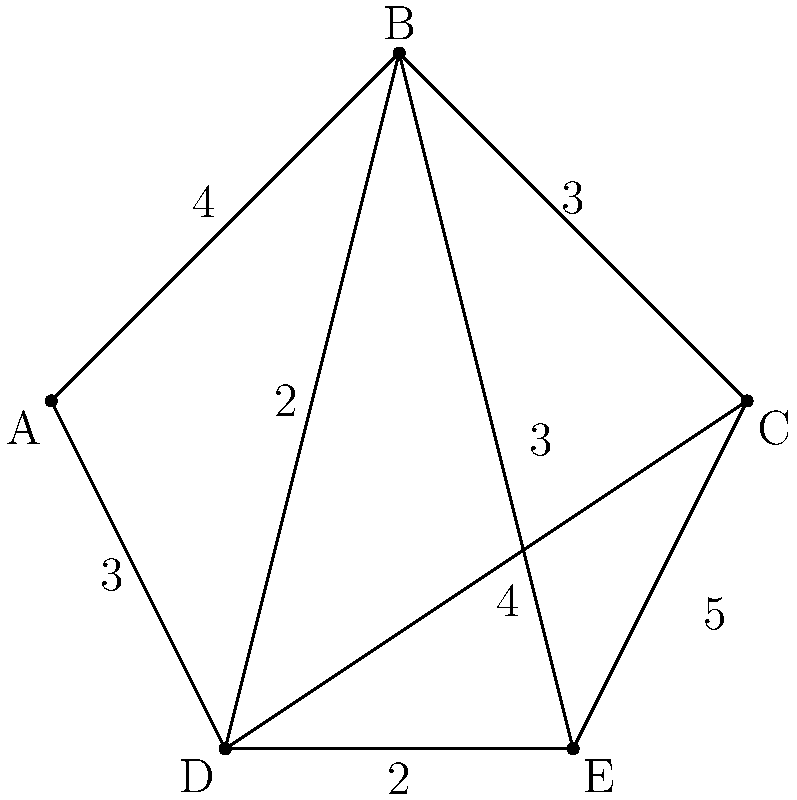As a project manager coordinating between a computer vision specialist and an engineer, you need to determine the most efficient route for data transfer in a network. Given the network diagram where nodes represent processing units and edge weights represent transfer times (in milliseconds), what is the shortest path that connects all nodes, starting and ending at node A? Provide the path and its total time. To find the shortest path that connects all nodes, starting and ending at node A, we need to solve the Traveling Salesman Problem (TSP). Since this is a small graph, we can use a step-by-step approach:

1. List all possible paths starting and ending at A that visit all nodes:
   - A-B-C-D-E-A
   - A-B-C-E-D-A
   - A-B-D-C-E-A
   - A-B-D-E-C-A
   - A-B-E-C-D-A
   - A-B-E-D-C-A
   - A-D-B-C-E-A
   - A-D-B-E-C-A
   - A-D-C-B-E-A
   - A-D-C-E-B-A
   - A-D-E-B-C-A
   - A-D-E-C-B-A

2. Calculate the total time for each path:
   - A-B-C-D-E-A: 4 + 3 + 4 + 2 + 3 = 16
   - A-B-C-E-D-A: 4 + 3 + 5 + 2 + 3 = 17
   - A-B-D-C-E-A: 4 + 2 + 4 + 5 + 3 = 18
   - A-B-D-E-C-A: 4 + 2 + 2 + 5 + 3 = 16
   - A-B-E-C-D-A: 4 + 3 + 5 + 4 + 3 = 19
   - A-B-E-D-C-A: 4 + 3 + 2 + 4 + 3 = 16
   - A-D-B-C-E-A: 3 + 2 + 3 + 5 + 3 = 16
   - A-D-B-E-C-A: 3 + 2 + 3 + 5 + 3 = 16
   - A-D-C-B-E-A: 3 + 4 + 3 + 3 + 3 = 16
   - A-D-C-E-B-A: 3 + 4 + 5 + 3 + 4 = 19
   - A-D-E-B-C-A: 3 + 2 + 3 + 3 + 3 = 14
   - A-D-E-C-B-A: 3 + 2 + 5 + 3 + 4 = 17

3. Identify the path with the shortest total time:
   The shortest path is A-D-E-B-C-A with a total time of 14 milliseconds.

This solution ensures that all nodes are visited once, starting and ending at node A, while minimizing the total transfer time.
Answer: A-D-E-B-C-A, 14 ms 